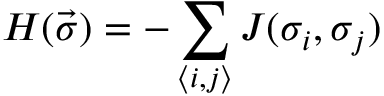Convert formula to latex. <formula><loc_0><loc_0><loc_500><loc_500>H ( \vec { \sigma } ) = - \sum _ { \langle i , j \rangle } J ( \sigma _ { i } , \sigma _ { j } )</formula> 